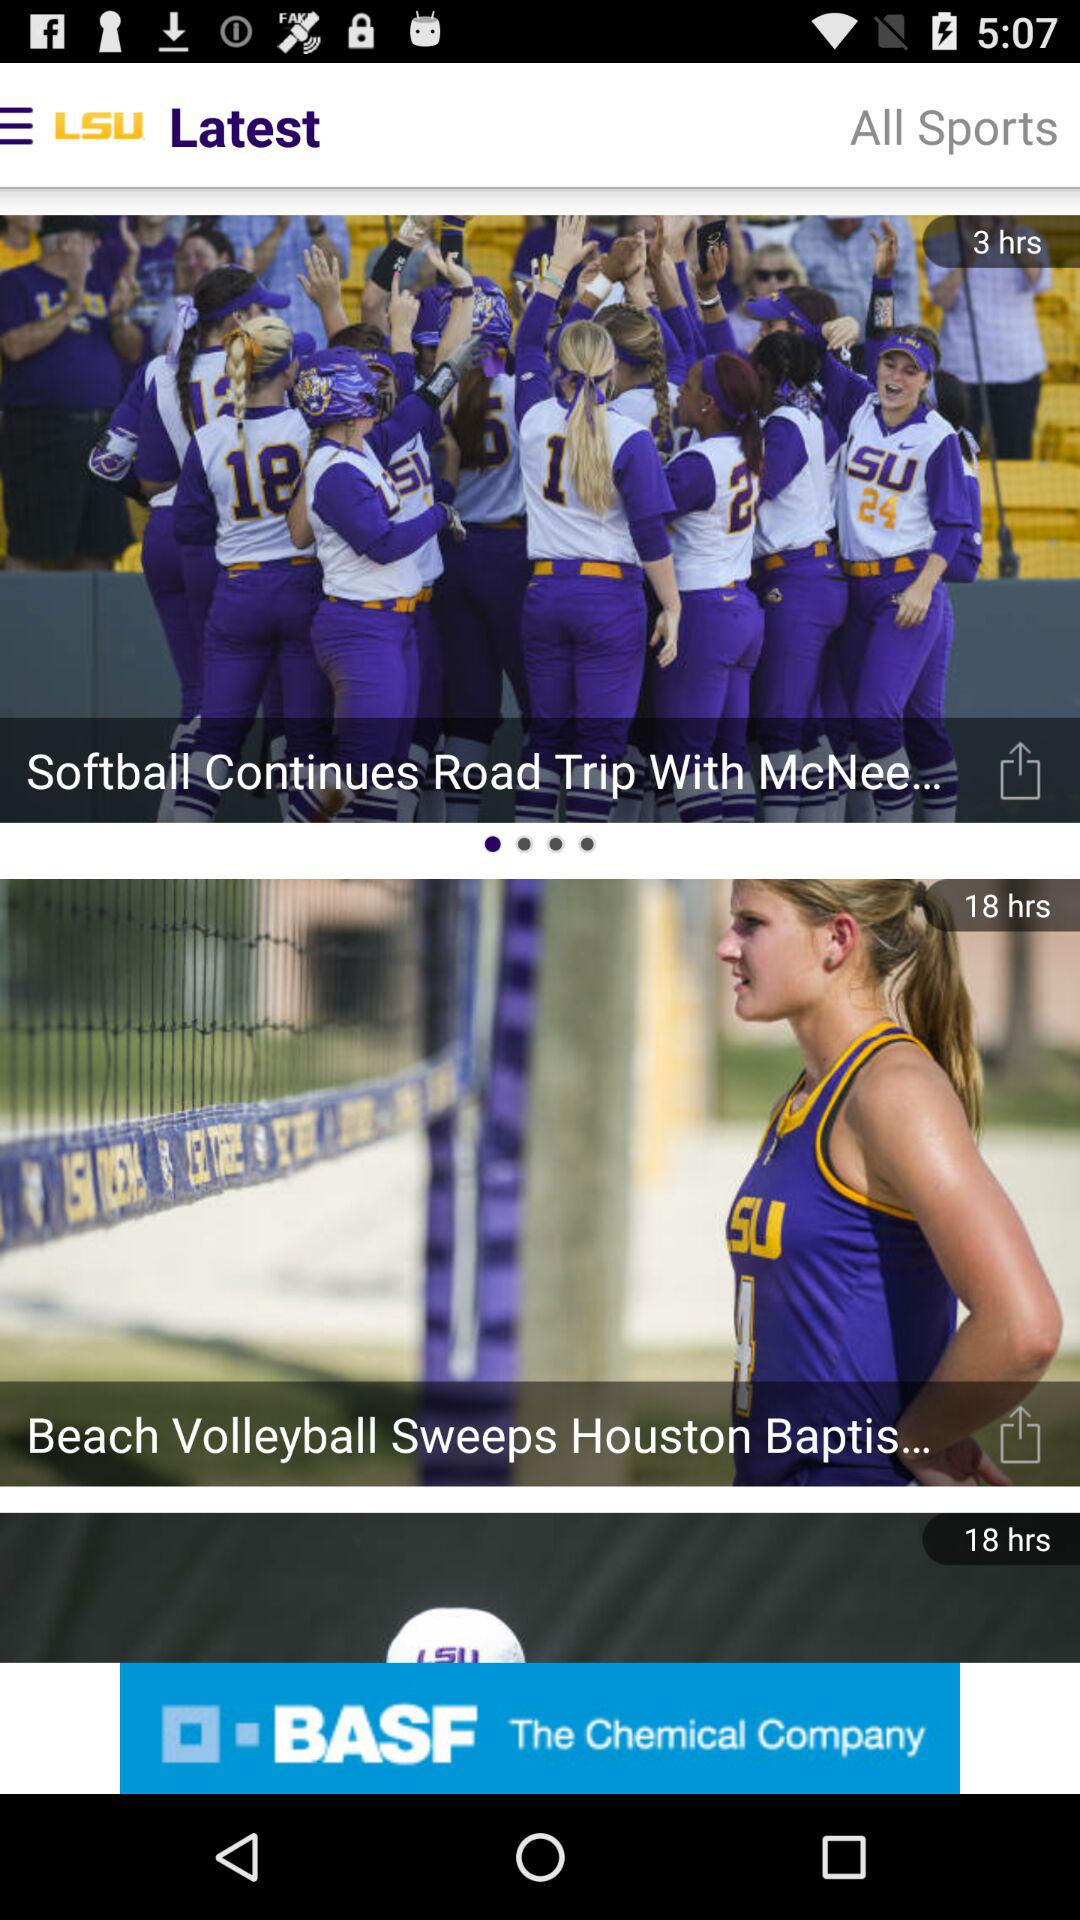What is the video length of "Beach Volleyball Sweeps Houston Baptist"? The length of the video is 18 hrs. 